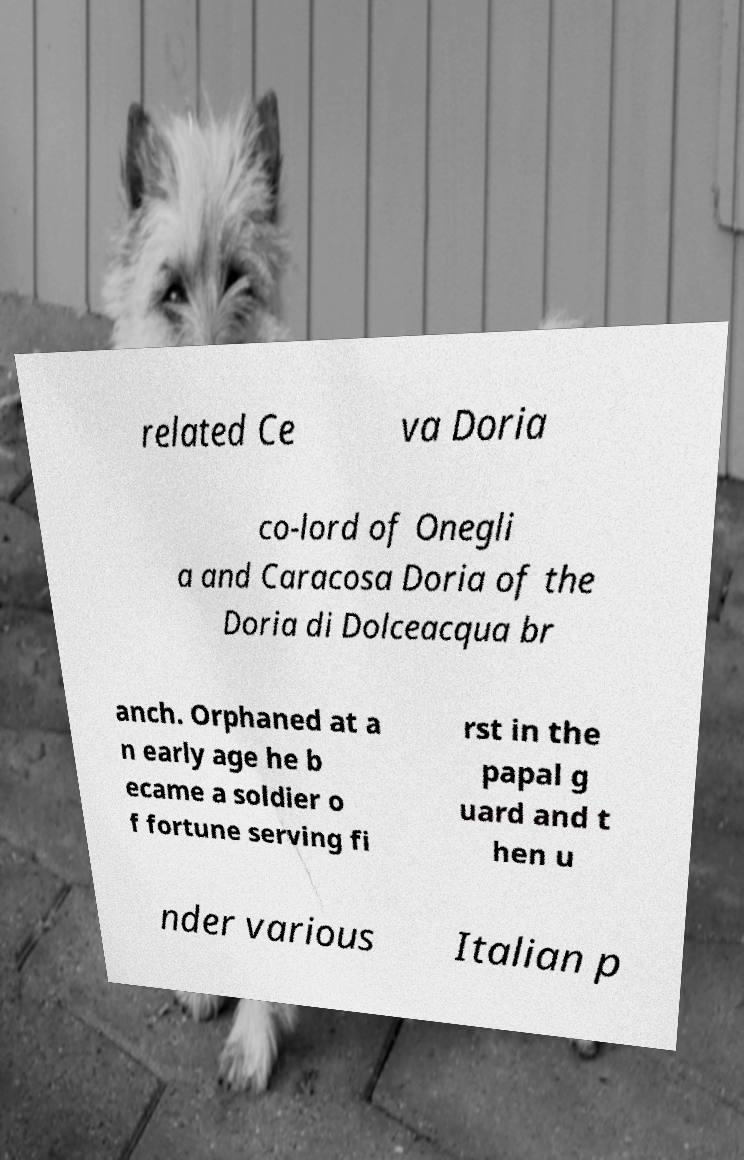Can you read and provide the text displayed in the image?This photo seems to have some interesting text. Can you extract and type it out for me? related Ce va Doria co-lord of Onegli a and Caracosa Doria of the Doria di Dolceacqua br anch. Orphaned at a n early age he b ecame a soldier o f fortune serving fi rst in the papal g uard and t hen u nder various Italian p 